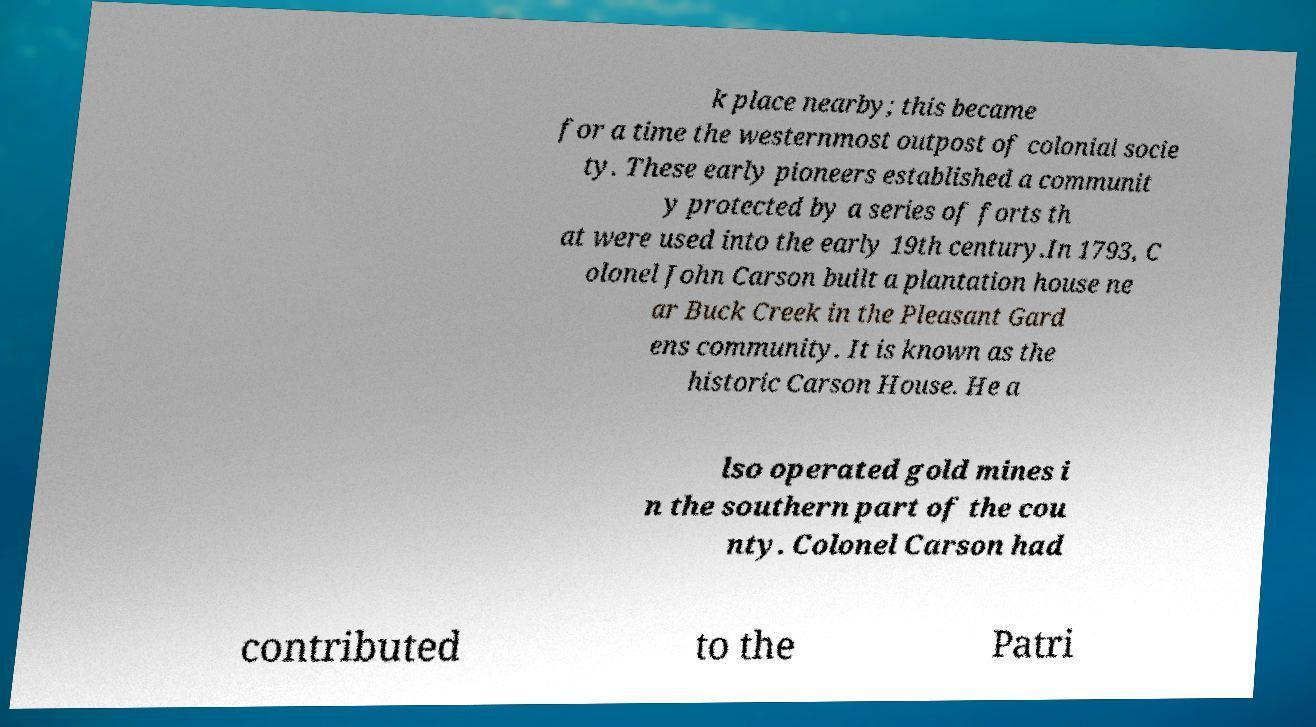Could you extract and type out the text from this image? k place nearby; this became for a time the westernmost outpost of colonial socie ty. These early pioneers established a communit y protected by a series of forts th at were used into the early 19th century.In 1793, C olonel John Carson built a plantation house ne ar Buck Creek in the Pleasant Gard ens community. It is known as the historic Carson House. He a lso operated gold mines i n the southern part of the cou nty. Colonel Carson had contributed to the Patri 